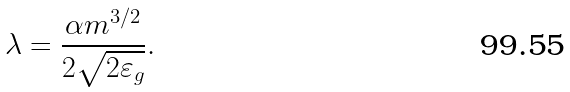<formula> <loc_0><loc_0><loc_500><loc_500>\lambda = \frac { \alpha m ^ { 3 / 2 } } { 2 \sqrt { 2 \varepsilon _ { g } } } .</formula> 